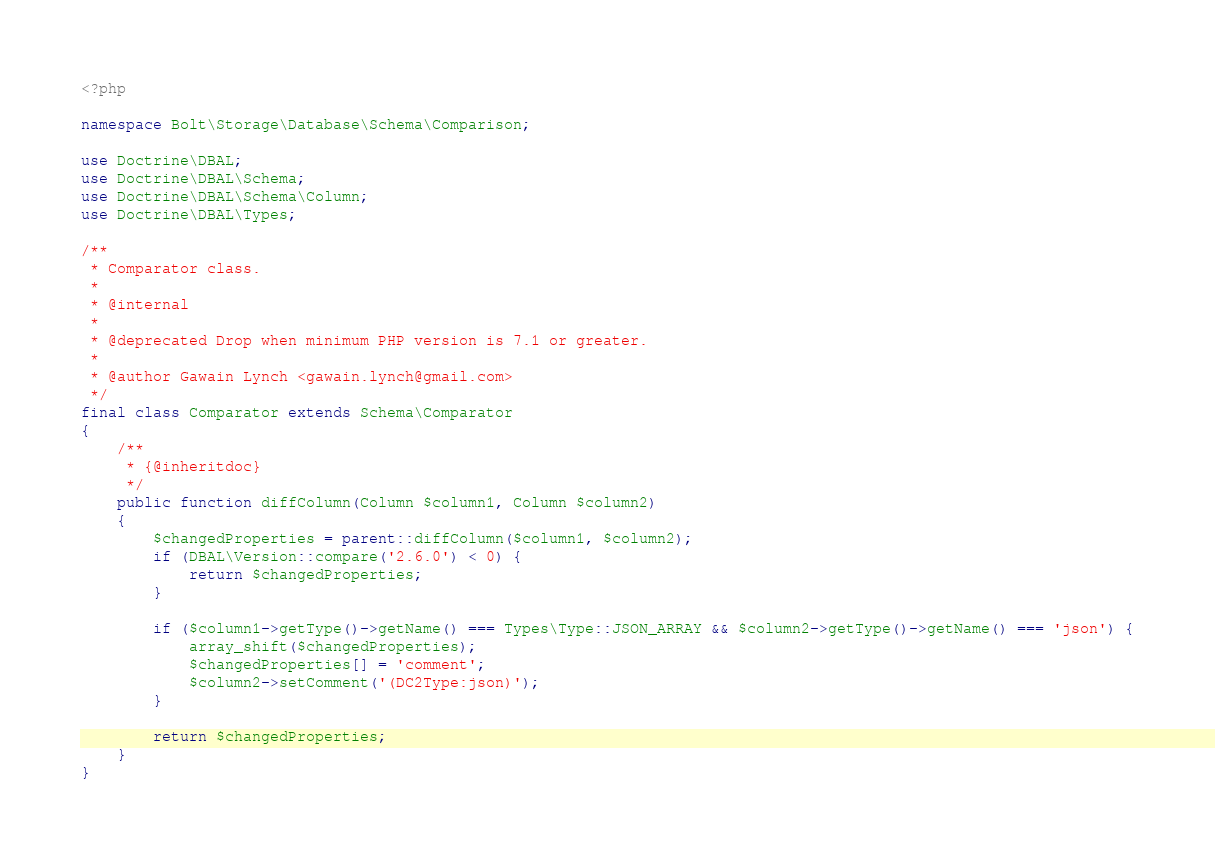<code> <loc_0><loc_0><loc_500><loc_500><_PHP_><?php

namespace Bolt\Storage\Database\Schema\Comparison;

use Doctrine\DBAL;
use Doctrine\DBAL\Schema;
use Doctrine\DBAL\Schema\Column;
use Doctrine\DBAL\Types;

/**
 * Comparator class.
 *
 * @internal
 *
 * @deprecated Drop when minimum PHP version is 7.1 or greater.
 *
 * @author Gawain Lynch <gawain.lynch@gmail.com>
 */
final class Comparator extends Schema\Comparator
{
    /**
     * {@inheritdoc}
     */
    public function diffColumn(Column $column1, Column $column2)
    {
        $changedProperties = parent::diffColumn($column1, $column2);
        if (DBAL\Version::compare('2.6.0') < 0) {
            return $changedProperties;
        }

        if ($column1->getType()->getName() === Types\Type::JSON_ARRAY && $column2->getType()->getName() === 'json') {
            array_shift($changedProperties);
            $changedProperties[] = 'comment';
            $column2->setComment('(DC2Type:json)');
        }

        return $changedProperties;
    }
}
</code> 